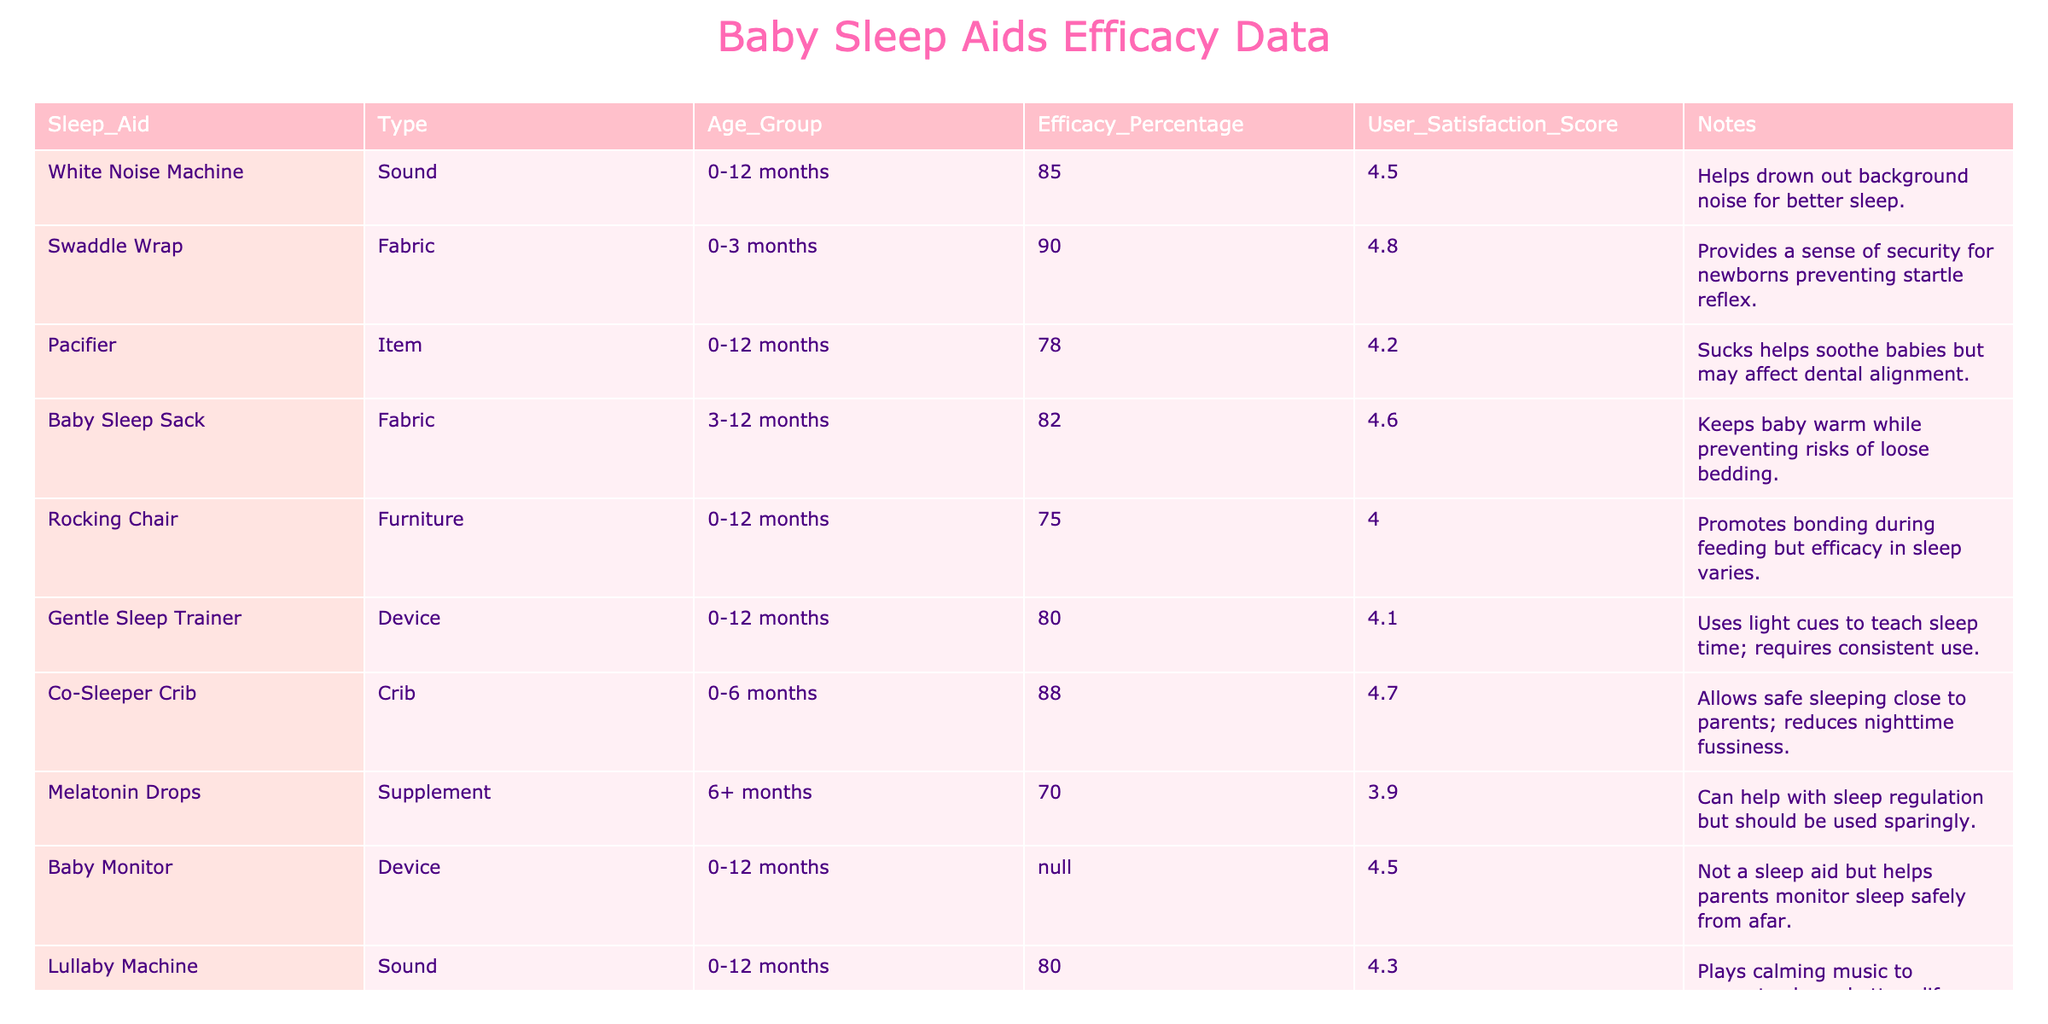What is the efficacy percentage of the Swaddle Wrap? The table shows that the Swaddle Wrap has an efficacy percentage of 90.
Answer: 90 Which sleep aid has the highest user satisfaction score? By reviewing the user satisfaction scores in the table, the Swaddle Wrap has the highest score of 4.8.
Answer: 4.8 Is the Baby Monitor considered a sleep aid? According to the table, the Baby Monitor is not labeled as a sleep aid, indicated by "N/A" under efficacy.
Answer: No What is the average efficacy percentage among the sleep aids for the age group 0-12 months? The efficacy percentages for sleep aids for this age group are: 85 (White Noise Machine), 90 (Swaddle Wrap), 78 (Pacifier), 82 (Baby Sleep Sack), 75 (Rocking Chair), 80 (Gentle Sleep Trainer), 88 (Co-Sleeper Crib), 80 (Lullaby Machine). To find the average, sum these values: 85 + 90 + 78 + 82 + 75 + 80 + 88 + 80 = 668. There are 8 values, so the average efficacy is 668 / 8 = 83.5.
Answer: 83.5 What sleep aid has a higher efficacy percentage: Co-Sleeper Crib or Gentle Sleep Trainer? The Co-Sleeper Crib has an efficacy percentage of 88, while the Gentle Sleep Trainer has 80. Since 88 is higher than 80, the Co-Sleeper Crib is more effective.
Answer: Co-Sleeper Crib How many sleep aids received a user satisfaction score of 4.5 or higher? By examining the user satisfaction scores, the following sleep aids have scores of 4.5 or above: White Noise Machine (4.5), Swaddle Wrap (4.8), Co-Sleeper Crib (4.7), Baby Monitor (4.5), Baby Sleep Sack (4.6), and Lullaby Machine (4.3). This totals to 6 sleep aids.
Answer: 6 What is the difference in efficacy percentage between the highest and lowest scoring sleep aids? The highest scoring sleep aid is the Swaddle Wrap with a percentage of 90, and the lowest is Melatonin Drops with 70. The difference is 90 - 70 = 20.
Answer: 20 Do the efficacy percentages correlate with user satisfaction scores for the products listed? To determine this, we look for patterns in the table: higher efficacy percentages generally correspond with higher user satisfaction scores, indicating a correlation. Specifically, the Swaddle Wrap has both high efficacy and satisfaction, while Melatonin Drops, with lower values in both areas, does not. Thus, while there’s a tendency for correlation, each product may have individual factors influencing scores.
Answer: Yes 